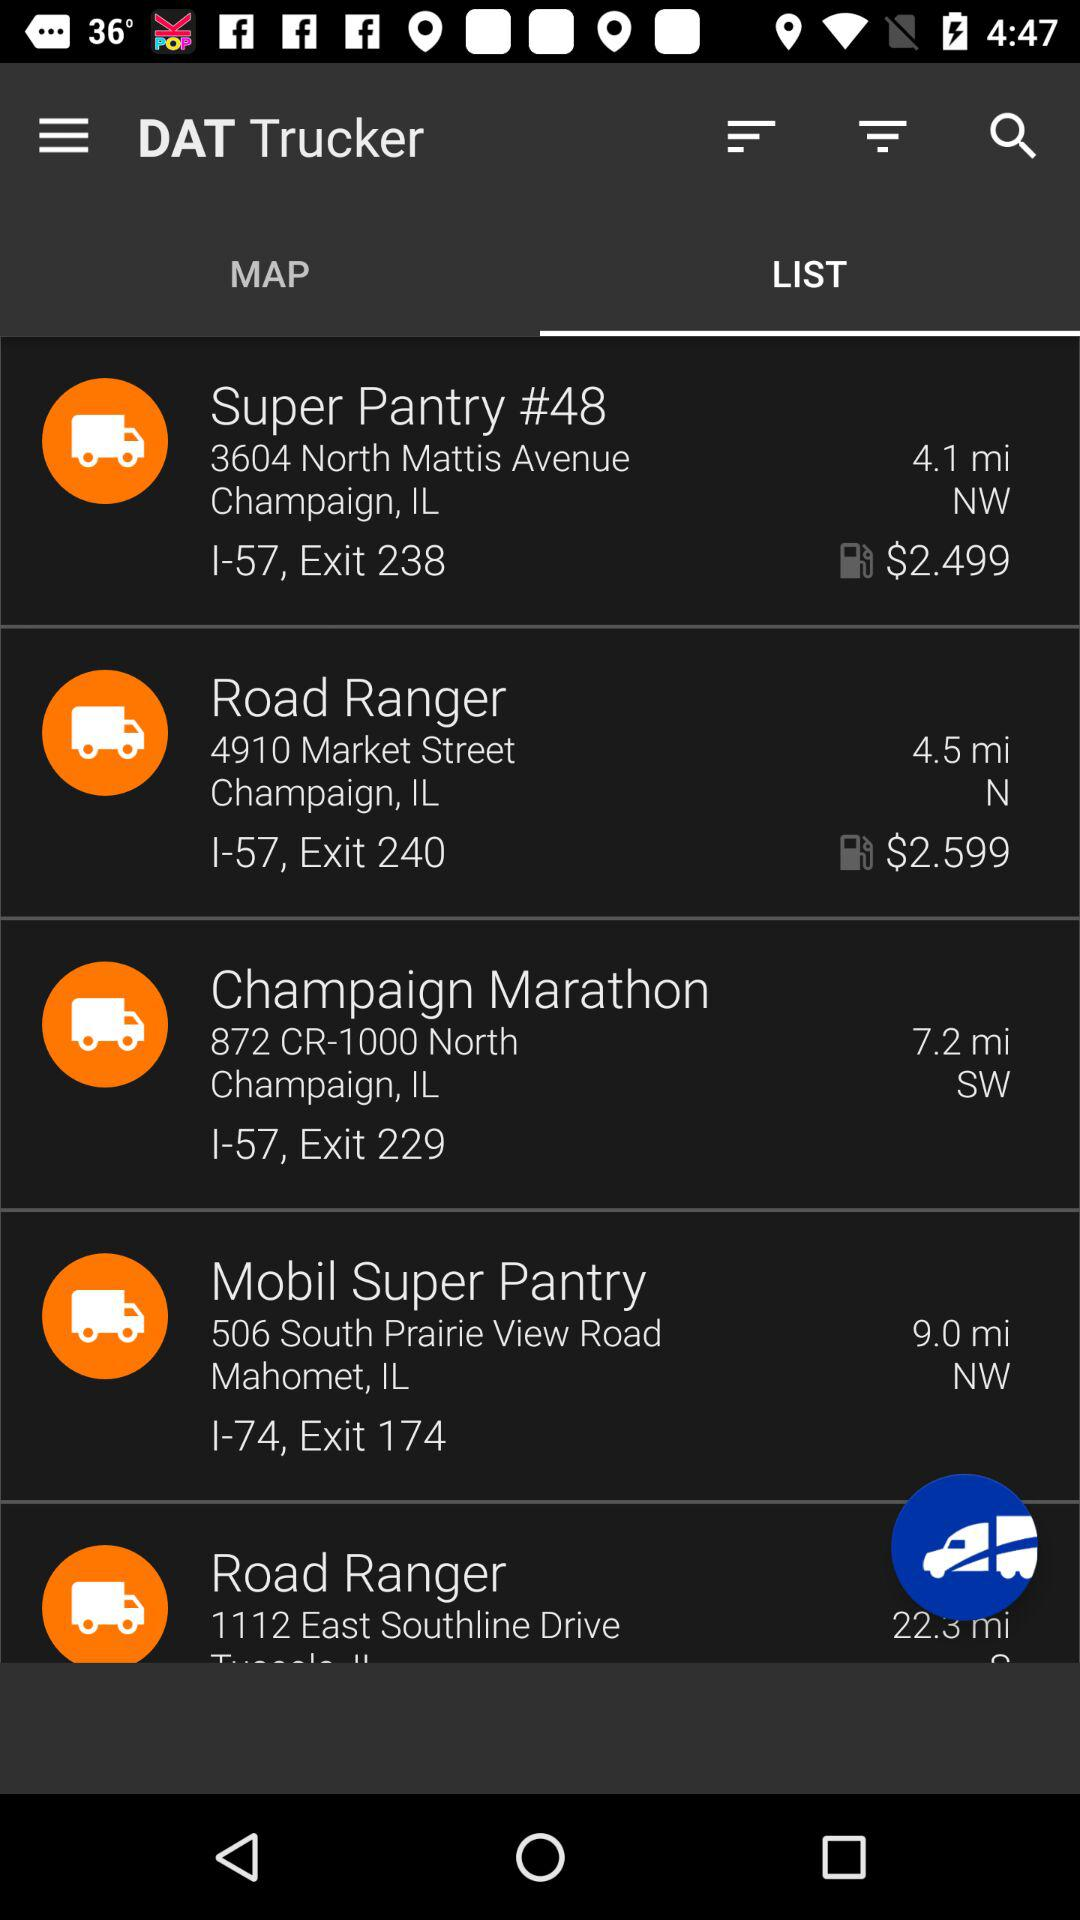Which gas station is furthest from the current location?
Answer the question using a single word or phrase. Road Ranger 